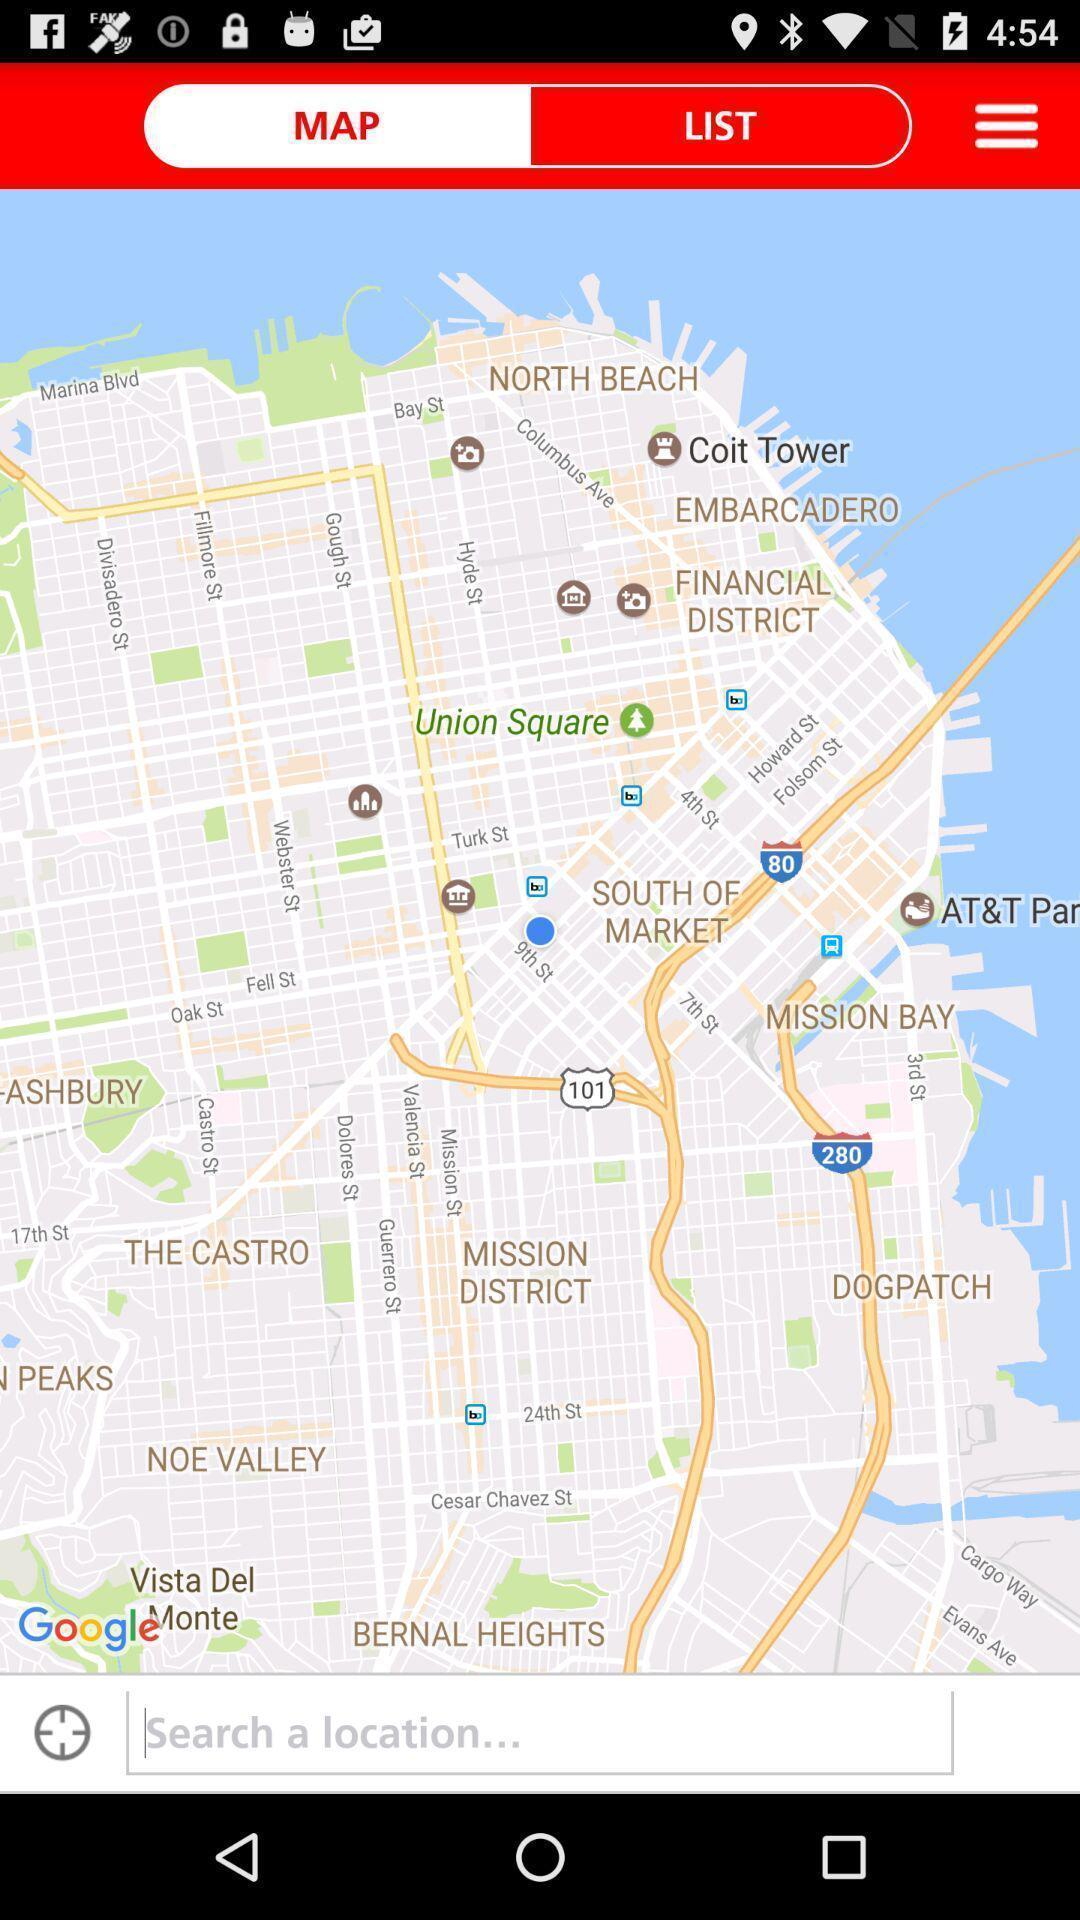Tell me about the visual elements in this screen capture. Search page for searching location on map for an app. 